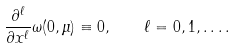Convert formula to latex. <formula><loc_0><loc_0><loc_500><loc_500>\frac { \partial ^ { \ell } } { \partial x ^ { \ell } } \omega ( 0 , \mu ) \equiv 0 , \quad \ell = 0 , 1 , \dots .</formula> 